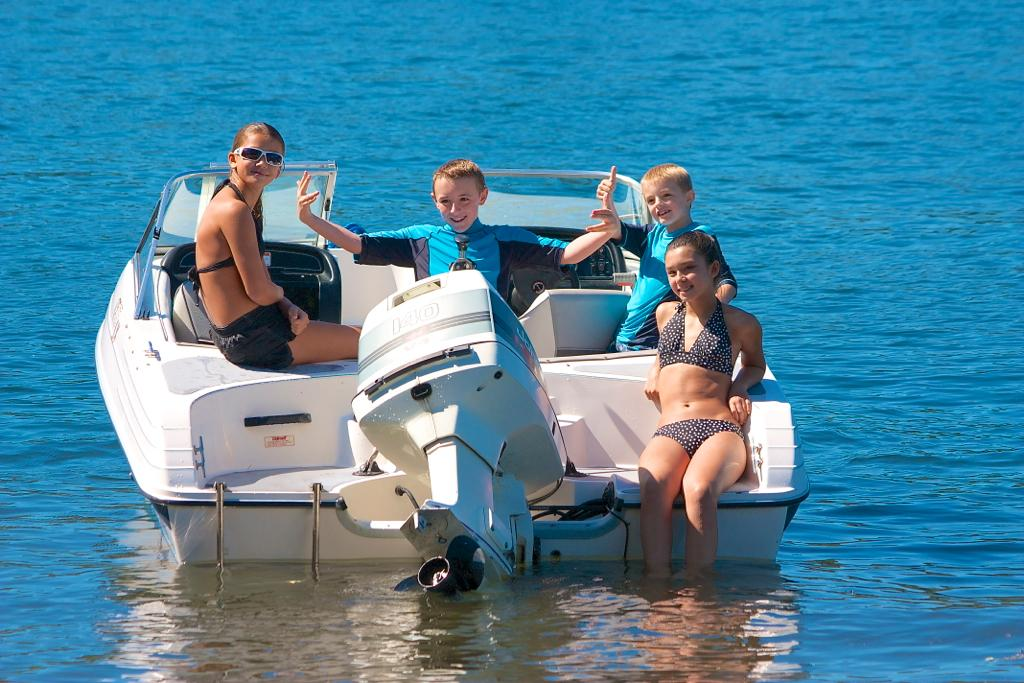What are the people in the image doing? The people in the image are seated in a boat. Can you describe the girl in the boat? The girl in the boat is seated, and her legs are in the water. What is the girl wearing in the image? The girl is wearing sunglasses. What type of credit card does the girl have in the image? There is no credit card visible in the image. What building can be seen in the background of the image? There is no building present in the image; it features a boat on water. 